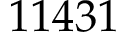Convert formula to latex. <formula><loc_0><loc_0><loc_500><loc_500>1 1 4 3 1</formula> 